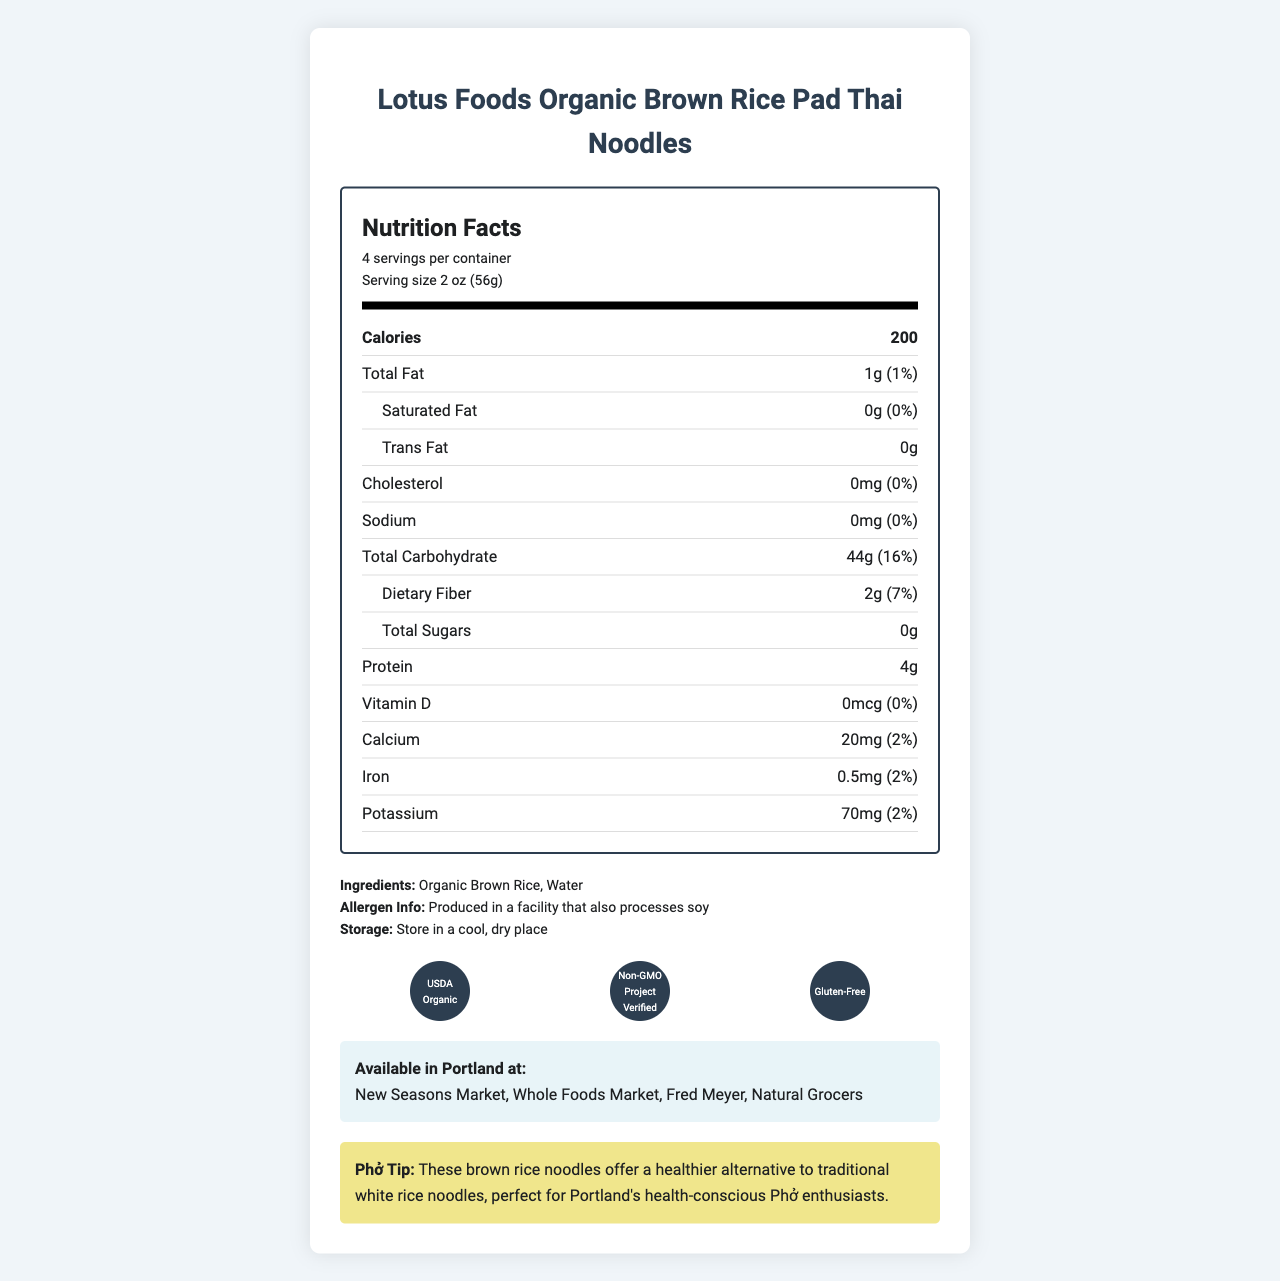what is the serving size? The serving size is displayed at the top of the nutrition facts section as "Serving size 2 oz (56g)".
Answer: 2 oz (56g) how many servings are in one container? The document states "4 servings per container" at the top of the nutrition facts section.
Answer: 4 how many calories are in one serving? The number of calories per serving is listed as "Calories 200" near the top of the nutrition facts section.
Answer: 200 what is the total fat content per serving? The total fat content per serving is listed as "Total Fat 1g" in the nutrition facts section.
Answer: 1g how much dietary fiber is in one serving? The dietary fiber content per serving is listed as "Dietary Fiber 2g" under the total carbohydrate section.
Answer: 2g what certifications does this product have? A. USDA Organic B. Non-GMO Project Verified C. Gluten-Free D. All of the above The certifications are represented with icons at the bottom of the document, showing USDA Organic, Non-GMO Project Verified, and Gluten-Free.
Answer: D. All of the above where can I buy this product in Portland? A. New Seasons Market B. Safeway C. Fred Meyer D. Natural Grocers E. all of the above except B The document lists availability at "New Seasons Market, Whole Foods Market, Fred Meyer, Natural Grocers" in the Portland section.
Answer: E. all of the above except B does this product contain any added sugars? The nutrition facts section lists "Total Sugars 0g", indicating there are no added sugars.
Answer: No is this product gluten-free? The certification icons at the bottom of the document include "Gluten-Free".
Answer: Yes what are the cooking instructions for this product? The instructions are listed at the bottom of the ingredients section.
Answer: Bring water to a boil. Add noodles and cook for 4-5 minutes or until tender. Drain and rinse with cold water. what is the brand name of these noodles? The brand name is the title of the document at the very top.
Answer: Lotus Foods Organic Brown Rice Pad Thai Noodles is there any sodium in this product? The sodium content is listed as "0mg" in the nutrition facts section.
Answer: No who is the target audience for the Phở tip provided in the document? The Phở tip at the bottom specifies that the brown rice noodles offer a healthier alternative to traditional white rice noodles, perfect for Portland's health-conscious Phở enthusiasts.
Answer: Portland's health-conscious Phở enthusiasts how much potassium is in one serving of these noodles? The amount of potassium per serving is listed as "Potassium 70mg" in the nutrition facts section.
Answer: 70mg what are the ingredients of this product? The ingredients are listed under the Ingredients section as "Organic Brown Rice, Water".
Answer: Organic Brown Rice, Water what is the cholesterol content per serving, and what percent of the daily value does it represent? The cholesterol content is listed as "0mg (0%)" in the nutrition facts section.
Answer: 0mg, 0% are there any specific allergen warnings for this product? The allergen information at the bottom of the ingredients section indicates a potential soy allergen.
Answer: Produced in a facility that also processes soy is this product recommended for people with soy allergies? The allergen information section states that the product is produced in a facility that processes soy, which may not be suitable for people with soy allergies.
Answer: No does this product include any added vitamins? The nutrition facts show 0% for Vitamin D, and there are no other added vitamins mentioned.
Answer: No what are the daily value percentages for calcium and iron? The daily value percentages for calcium and iron are listed as 2% in the nutrition facts section.
Answer: Calcium: 2%, Iron: 2% does the document provide information on whether the package is recyclable? The document does not mention anything about the recyclability of the package.
Answer: Not enough information 